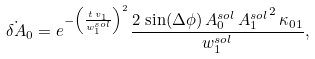Convert formula to latex. <formula><loc_0><loc_0><loc_500><loc_500>\dot { \delta A } _ { 0 } = e ^ { - \left ( \frac { t \, v _ { 1 } } { w _ { 1 } ^ { s o l } } \right ) ^ { 2 } } \frac { 2 \, \sin ( \Delta \phi ) \, A _ { 0 } ^ { s o l } \, { A _ { 1 } ^ { s o l } } ^ { 2 } \, { { \kappa } _ { 0 1 } } } { w _ { 1 } ^ { s o l } } ,</formula> 